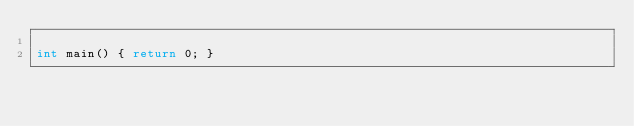<code> <loc_0><loc_0><loc_500><loc_500><_C++_>
int main() { return 0; }
</code> 